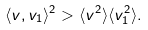Convert formula to latex. <formula><loc_0><loc_0><loc_500><loc_500>\langle v , v _ { 1 } \rangle ^ { 2 } > \langle v ^ { 2 } \rangle \langle v _ { 1 } ^ { 2 } \rangle .</formula> 